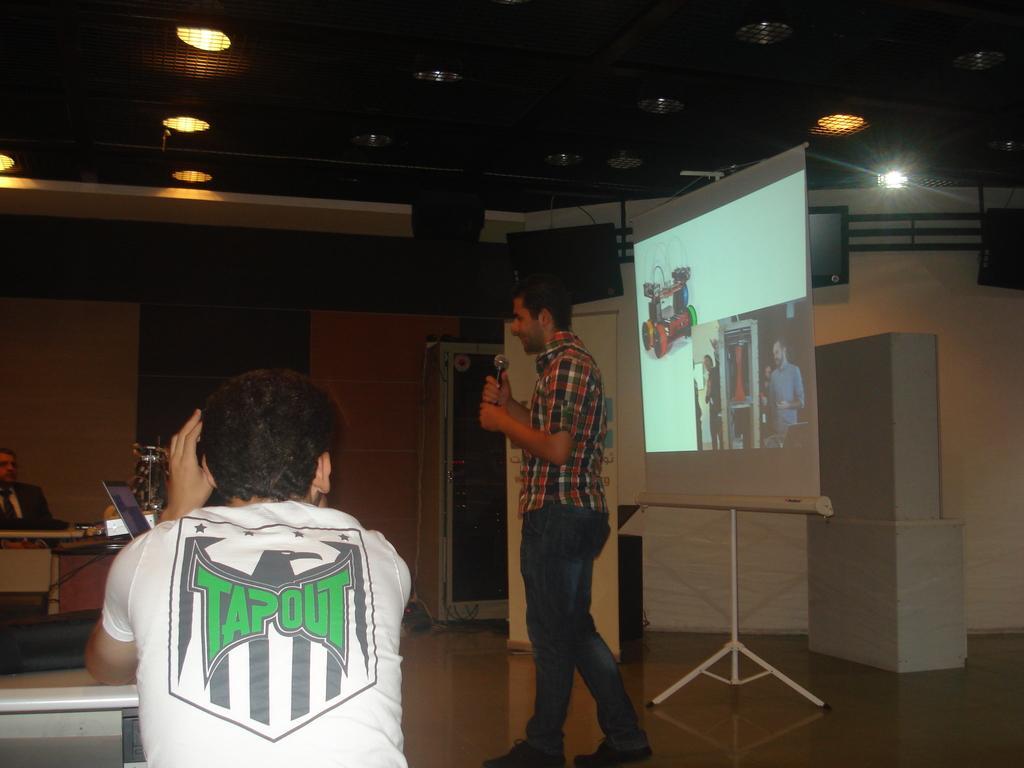How would you summarize this image in a sentence or two? Lights are attached to the ceiling. A person is standing and holding a mic. Backside of this person there is a screen, hoarding and televisions. In-front of this person there are tables, people and laptop. Far there is a door. 